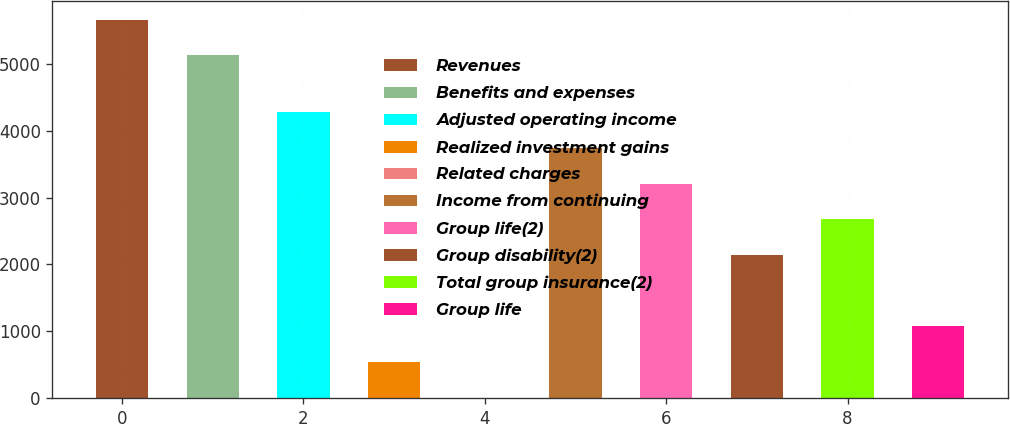Convert chart. <chart><loc_0><loc_0><loc_500><loc_500><bar_chart><fcel>Revenues<fcel>Benefits and expenses<fcel>Adjusted operating income<fcel>Realized investment gains<fcel>Related charges<fcel>Income from continuing<fcel>Group life(2)<fcel>Group disability(2)<fcel>Total group insurance(2)<fcel>Group life<nl><fcel>5656.7<fcel>5123<fcel>4275.6<fcel>539.7<fcel>6<fcel>3741.9<fcel>3208.2<fcel>2140.8<fcel>2674.5<fcel>1073.4<nl></chart> 